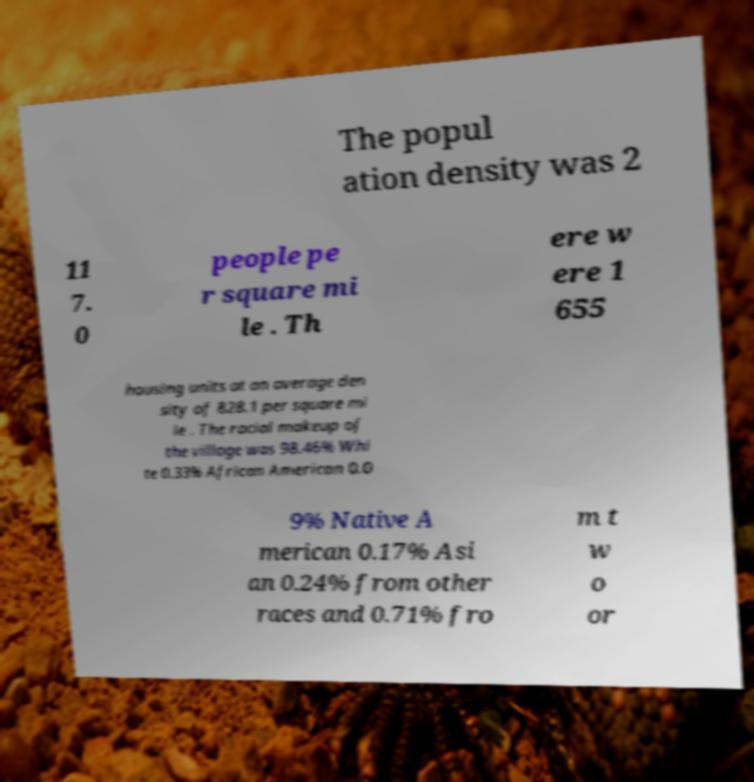There's text embedded in this image that I need extracted. Can you transcribe it verbatim? The popul ation density was 2 11 7. 0 people pe r square mi le . Th ere w ere 1 655 housing units at an average den sity of 828.1 per square mi le . The racial makeup of the village was 98.46% Whi te 0.33% African American 0.0 9% Native A merican 0.17% Asi an 0.24% from other races and 0.71% fro m t w o or 